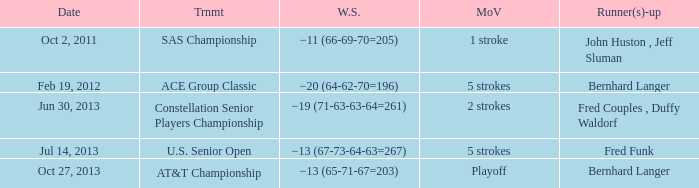Which Date has a Runner(s)-up of bernhard langer, and a Tournament of at&t championship? Oct 27, 2013. 